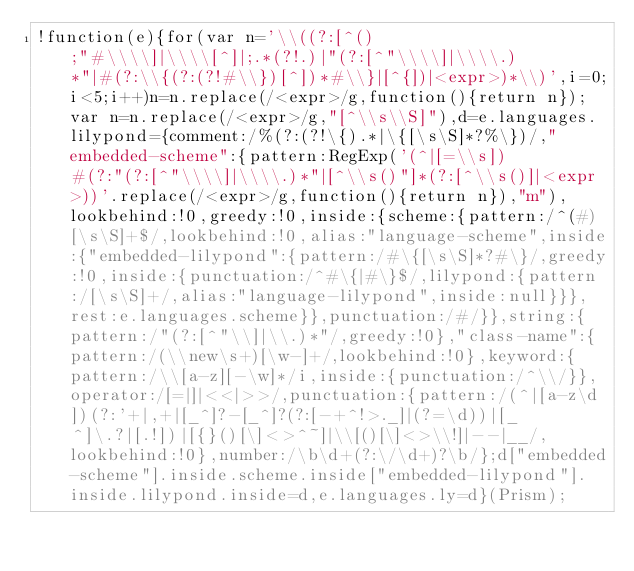Convert code to text. <code><loc_0><loc_0><loc_500><loc_500><_JavaScript_>!function(e){for(var n='\\((?:[^();"#\\\\]|\\\\[^]|;.*(?!.)|"(?:[^"\\\\]|\\\\.)*"|#(?:\\{(?:(?!#\\})[^])*#\\}|[^{])|<expr>)*\\)',i=0;i<5;i++)n=n.replace(/<expr>/g,function(){return n});var n=n.replace(/<expr>/g,"[^\\s\\S]"),d=e.languages.lilypond={comment:/%(?:(?!\{).*|\{[\s\S]*?%\})/,"embedded-scheme":{pattern:RegExp('(^|[=\\s])#(?:"(?:[^"\\\\]|\\\\.)*"|[^\\s()"]*(?:[^\\s()]|<expr>))'.replace(/<expr>/g,function(){return n}),"m"),lookbehind:!0,greedy:!0,inside:{scheme:{pattern:/^(#)[\s\S]+$/,lookbehind:!0,alias:"language-scheme",inside:{"embedded-lilypond":{pattern:/#\{[\s\S]*?#\}/,greedy:!0,inside:{punctuation:/^#\{|#\}$/,lilypond:{pattern:/[\s\S]+/,alias:"language-lilypond",inside:null}}},rest:e.languages.scheme}},punctuation:/#/}},string:{pattern:/"(?:[^"\\]|\\.)*"/,greedy:!0},"class-name":{pattern:/(\\new\s+)[\w-]+/,lookbehind:!0},keyword:{pattern:/\\[a-z][-\w]*/i,inside:{punctuation:/^\\/}},operator:/[=|]|<<|>>/,punctuation:{pattern:/(^|[a-z\d])(?:'+|,+|[_^]?-[_^]?(?:[-+^!>._]|(?=\d))|[_^]\.?|[.!])|[{}()[\]<>^~]|\\[()[\]<>\\!]|--|__/,lookbehind:!0},number:/\b\d+(?:\/\d+)?\b/};d["embedded-scheme"].inside.scheme.inside["embedded-lilypond"].inside.lilypond.inside=d,e.languages.ly=d}(Prism);</code> 